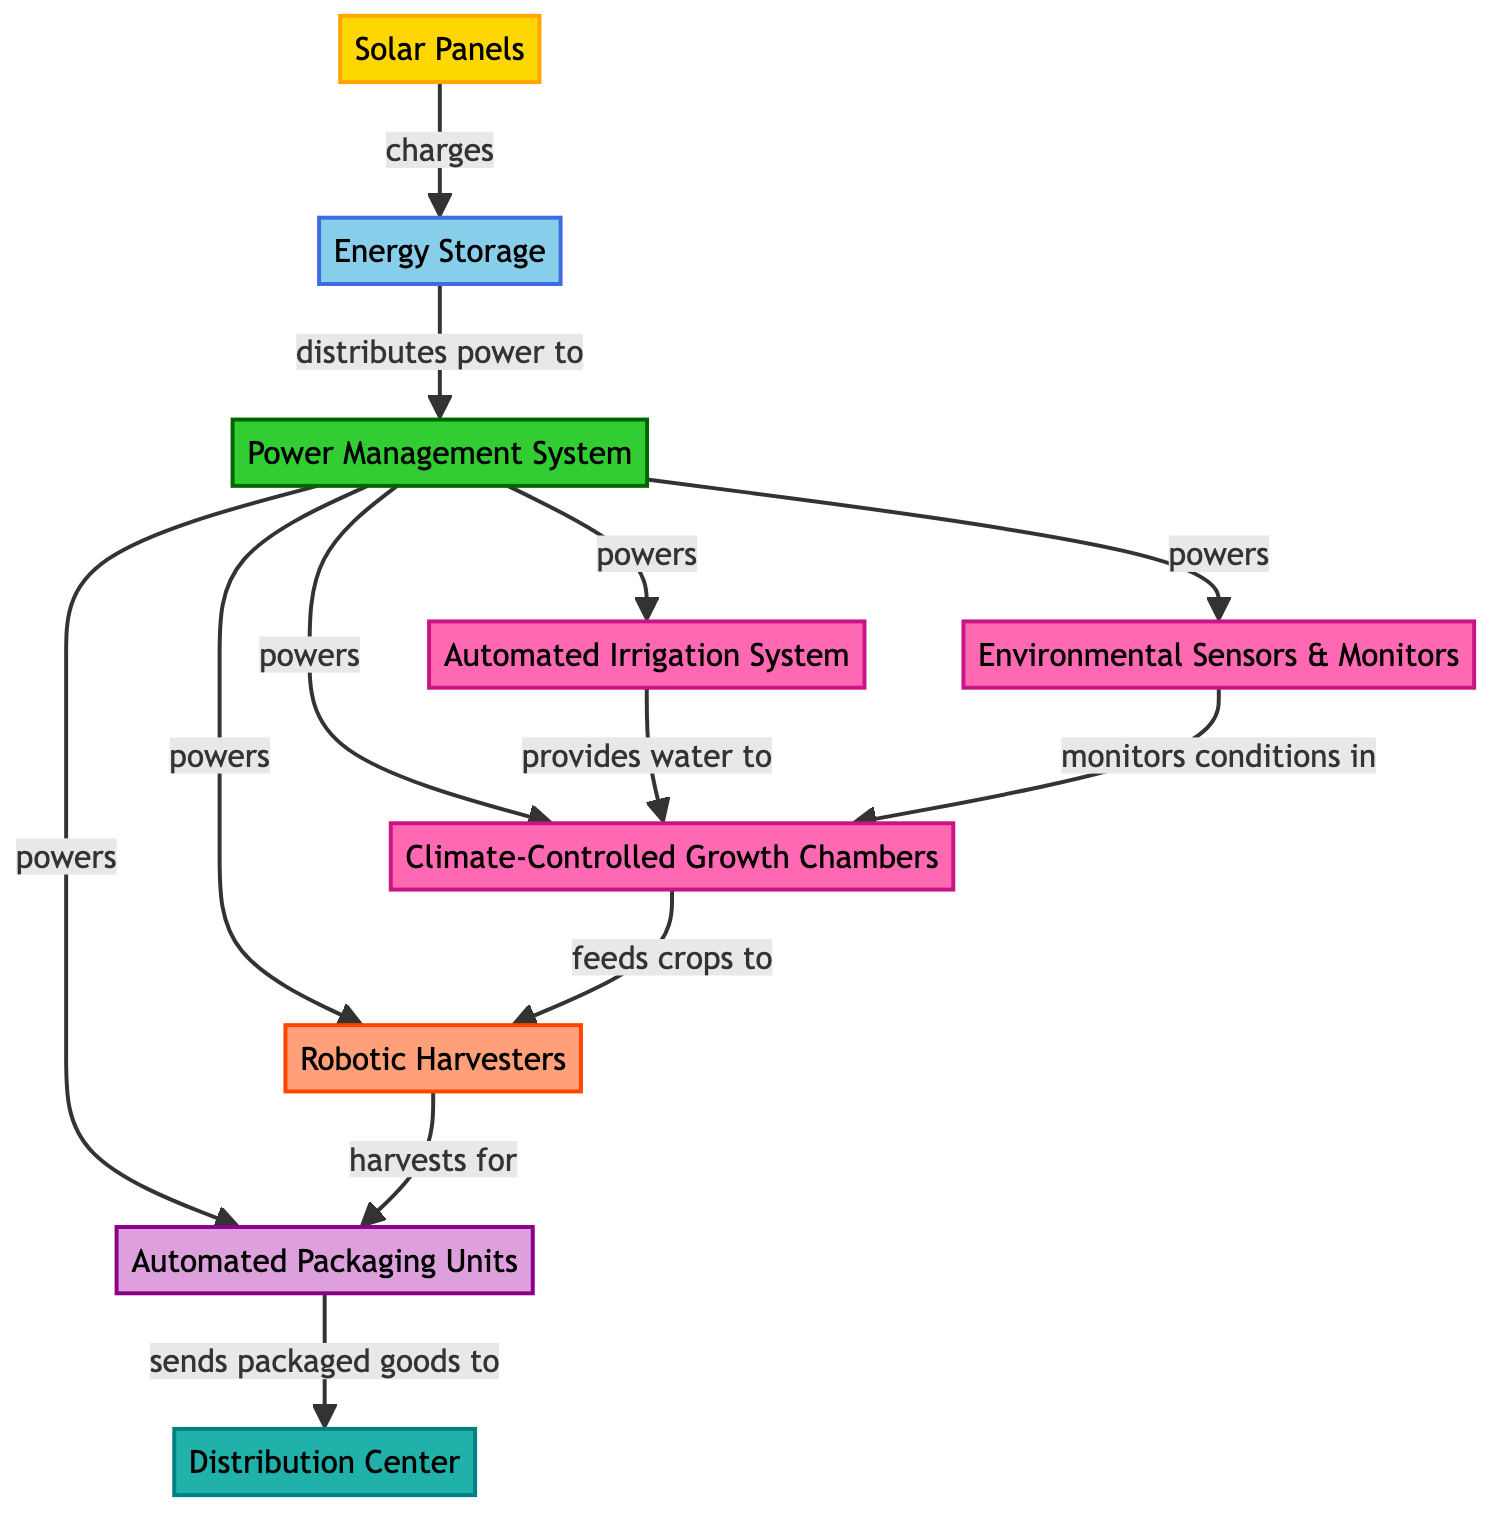What is the first element in the energy flow? The first element in the energy flow is the Solar Panels, which initiate the process by capturing solar energy.
Answer: Solar Panels How many systems are powered by the Power Management System? The Power Management System powers four systems: the Automated Irrigation System, Environmental Sensors & Monitors, Climate-Controlled Growth Chambers, and Robotic Harvesters.
Answer: Four Which element monitors conditions in the Climate-Controlled Growth Chambers? The Environmental Sensors & Monitors are responsible for monitoring the conditions inside the Climate-Controlled Growth Chambers to ensure optimal growth conditions.
Answer: Environmental Sensors & Monitors What does the Automated Irrigation System provide to the Climate-Controlled Growth Chambers? The Automated Irrigation System provides water to the Climate-Controlled Growth Chambers, which is essential for the growth of crops.
Answer: Water What is the last step in the food production chain? The last step in the food production chain is the Distribution Center, where the packaged goods are sent for distribution.
Answer: Distribution Center Which node directly receives harvested goods from the Robotic Harvesters? The Automated Packaging Units directly receive the harvested goods from the Robotic Harvesters for packaging and processing.
Answer: Automated Packaging Units How does the energy flow from Solar Panels to the Environmental Sensors & Monitors? Energy flows from the Solar Panels to Energy Storage, and then it is distributed by the Power Management System to power the Environmental Sensors & Monitors.
Answer: Through Energy Storage and Power Management System Which element feeds crops to the Robotic Harvesters? The Climate-Controlled Growth Chambers feed crops to the Robotic Harvesters, which then process these crops for packaging.
Answer: Climate-Controlled Growth Chambers How does the flow of energy connect the Robotic Harvesters and the Automated Packaging Units? The Robotic Harvesters harvest crops and directly send them to the Automated Packaging Units for further processing and packaging.
Answer: Directly 